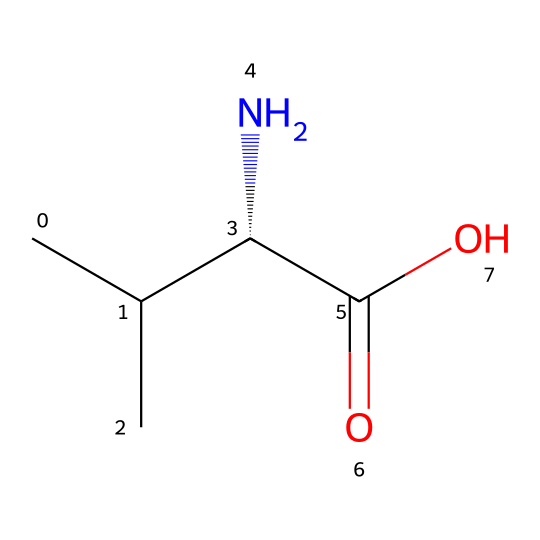How many carbon atoms are in this compound? The SMILES representation indicates the number of carbon atoms in the structure. By counting "C" in the representation, we find a total of five carbon atoms including the one that is part of the chiral center.
Answer: five What is the functional group present in the compound? The presence of "C(=O)O" in the SMILES indicates a carboxylic acid functional group, where "C(=O)" denotes a carbonyl group and "O" indicates a hydroxyl group attached to the same carbon.
Answer: carboxylic acid What is the stereocenter position in this molecule? The "C@H" in the SMILES denotes that there is a chiral center at the given carbon atom, indicating its stereochemistry, which means it is the fourth carbon in the chain counting from the left side.
Answer: fourth carbon Does this compound exhibit chirality? The presence of a chiral center (the carbon with "C@H") means that this compound can exist in two non-superimposable mirror images, thus confirming its chirality.
Answer: yes What type of amino acid does this structure represent? The structure closely resembles an amino acid with a carboxylic acid group and an amino group (-NH2), specifically it represents L-leucine, an essential amino acid.
Answer: L-leucine What is the total number of hydrogen atoms in this compound? By analyzing the structure, each carbon typically has enough hydrogen atoms to fulfill its tetravalency. The SMILES notation can be broken down to count hydrogens. There are a total of 11 hydrogen atoms.
Answer: eleven What is the molecular formula of this compound? The molecular formula can be derived by counting all types of atoms in the structure as represented in the SMILES. Specifically, there are 5 carbons, 11 hydrogens, 1 nitrogen, and 2 oxygens in the molecule. Thus, the molecular formula is C5H11NO2.
Answer: C5H11NO2 